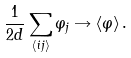Convert formula to latex. <formula><loc_0><loc_0><loc_500><loc_500>\frac { 1 } { 2 d } \sum _ { \langle i j \rangle } \varphi _ { j } \rightarrow \left \langle \varphi \right \rangle .</formula> 